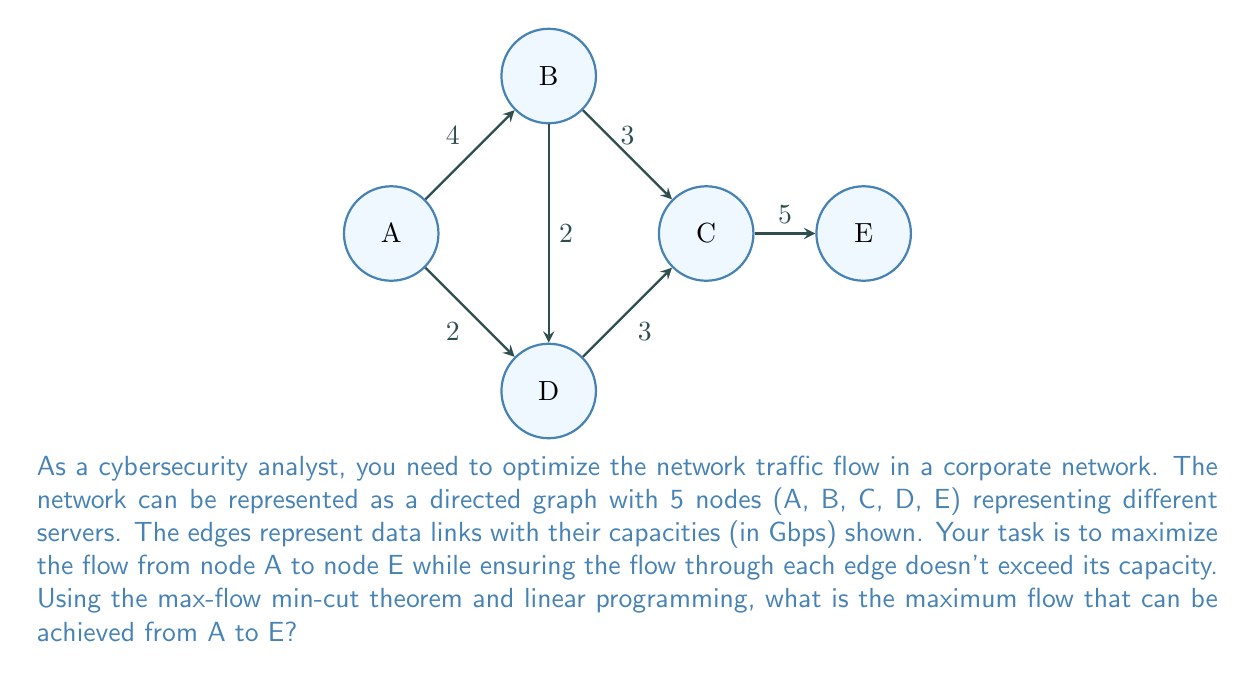Teach me how to tackle this problem. To solve this problem, we'll use the max-flow min-cut theorem and formulate it as a linear programming problem.

Step 1: Define variables
Let $x_{ij}$ represent the flow from node i to node j.

Step 2: Formulate the objective function
Maximize: $Z = x_{AE}$ (total flow from A to E)

Step 3: Set up constraints
Flow conservation constraints:
$$x_{AB} + x_{AD} = x_{AE}$$ (flow out of A equals flow into E)
$$x_{AB} = x_{BC} + x_{BD}$$ (flow into B equals flow out of B)
$$x_{AD} + x_{BD} = x_{DC}$$ (flow into D equals flow out of D)
$$x_{BC} + x_{DC} = x_{CE}$$ (flow into C equals flow out of C)

Capacity constraints:
$$x_{AB} \leq 4$$
$$x_{BC} \leq 3$$
$$x_{CE} \leq 5$$
$$x_{AD} \leq 2$$
$$x_{DC} \leq 3$$
$$x_{BD} \leq 2$$

Non-negativity constraints:
$$x_{ij} \geq 0$$ for all i, j

Step 4: Solve the linear programming problem
Using a linear programming solver or the simplex method, we can solve this system of equations and inequalities.

Step 5: Interpret the results
The solution gives us the maximum flow from A to E, which is 7 Gbps.

This can be achieved by:
- Sending 4 Gbps through path A -> B -> C -> E
- Sending 2 Gbps through path A -> D -> C -> E
- Sending 1 Gbps through path A -> B -> D -> C -> E

The min-cut in this case is {(B,C), (D,C), (C,E)}, which has a total capacity of 3 + 3 + 5 = 11 Gbps, verifying our max-flow result.
Answer: 7 Gbps 